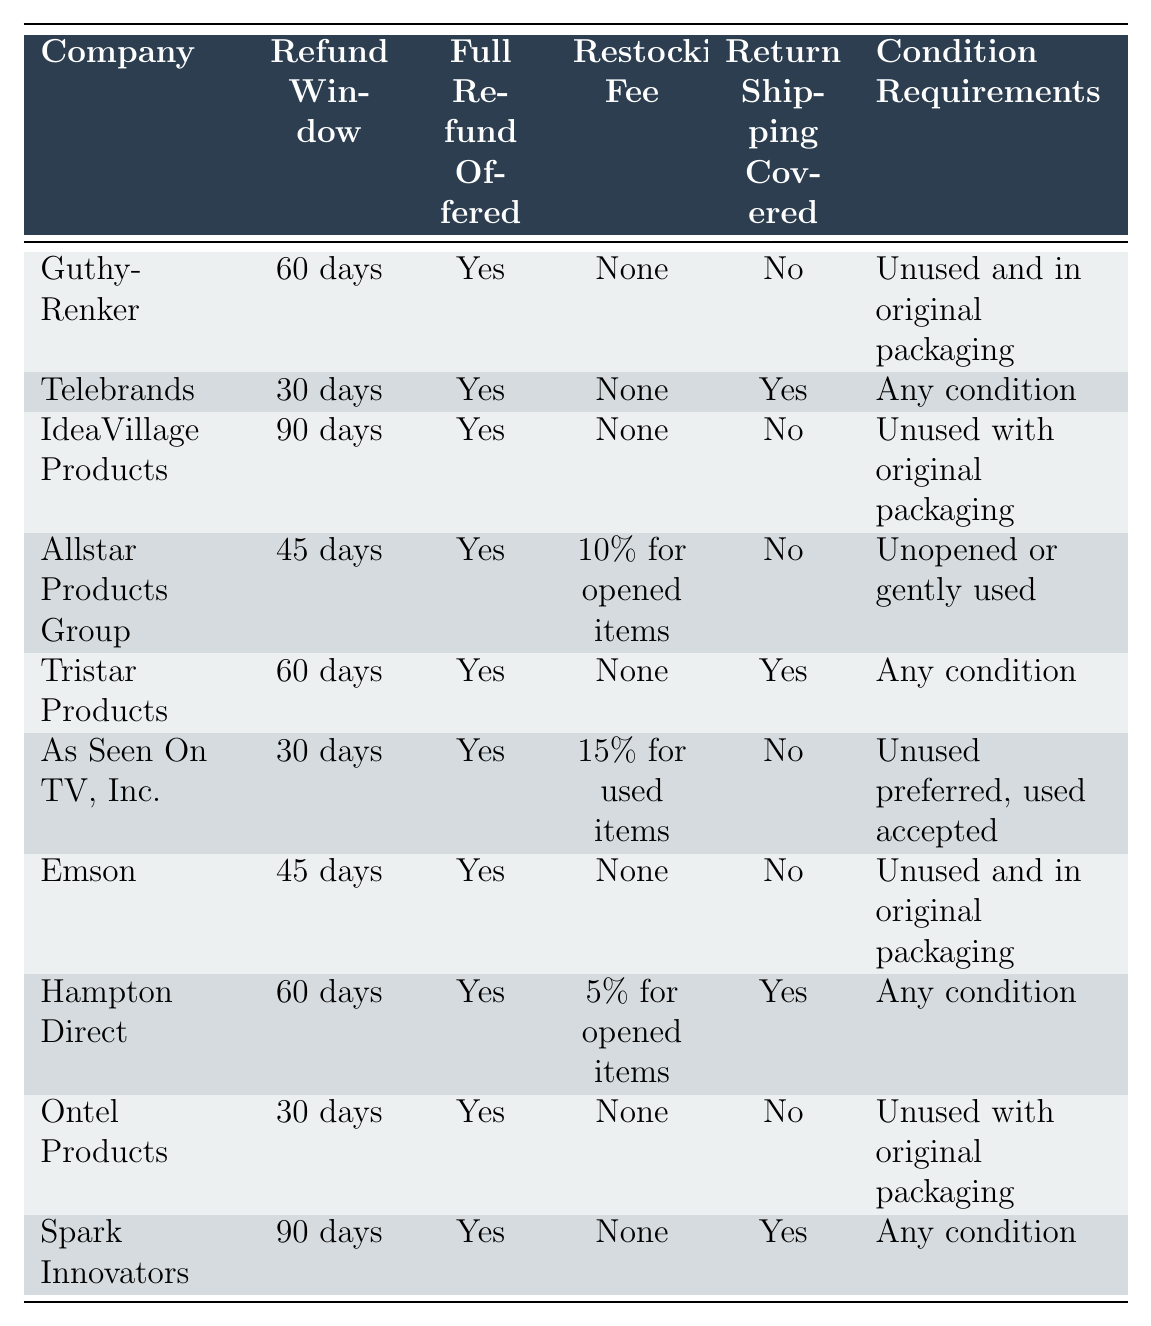What is the refund window for Telebrands? Telebrands has a refund window of 30 days, as stated in the table.
Answer: 30 days Which company offers a full refund without a restocking fee? Companies like Guthy-Renker, Telebrands, Tristar Products, Emson, and Spark Innovators offer a full refund without a restocking fee, as indicated in the table.
Answer: Guthy-Renker, Telebrands, Tristar Products, Emson, Spark Innovators Is there a company that covers return shipping? Yes, Telebrands, Tristar Products, and Hampton Direct cover return shipping, according to the table.
Answer: Yes What is the condition requirement for returning products to IdeaVillage Products? The condition requirement for returning products to IdeaVillage Products is that they must be unused with original packaging, as per the table.
Answer: Unused with original packaging Which company has the longest refund window? IdeaVillage Products has the longest refund window of 90 days, which can be found in the table under the refund window column.
Answer: IdeaVillage Products What percentage restocking fee do opened items incur at Allstar Products Group? Allstar Products Group charges a 10% restocking fee for opened items, as listed in the table.
Answer: 10% Which companies do not have any restocking fees? Guthy-Renker, Telebrands, Tristar Products, Emson, and Spark Innovators do not have any restocking fees according to the table.
Answer: Guthy-Renker, Telebrands, Tristar Products, Emson, Spark Innovators For companies that accept returns in any condition, what are their refund windows? Tristar Products has a refund window of 60 days, and Telebrands has a refund window of 30 days, both of which accept returns in any condition according to the table.
Answer: 60 days, 30 days How many companies offer a full refund but have conditions on the items being returned? Allstar Products Group requires items to be unopened or gently used, As Seen On TV, Inc. prefers unused but accepts used, and Emson requires items to be unused in original packaging. In total, there are three companies.
Answer: 3 Which company has a shorter refund window: Ontel Products or As Seen On TV, Inc.? Ontel Products has a refund window of 30 days, while As Seen On TV, Inc. also has a refund window of 30 days. Therefore, they have the same length refund windows.
Answer: Same length (30 days) 